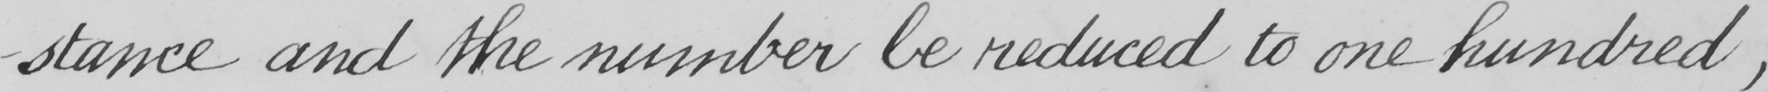Transcribe the text shown in this historical manuscript line. -stance and the number be reduced to one hundred , 